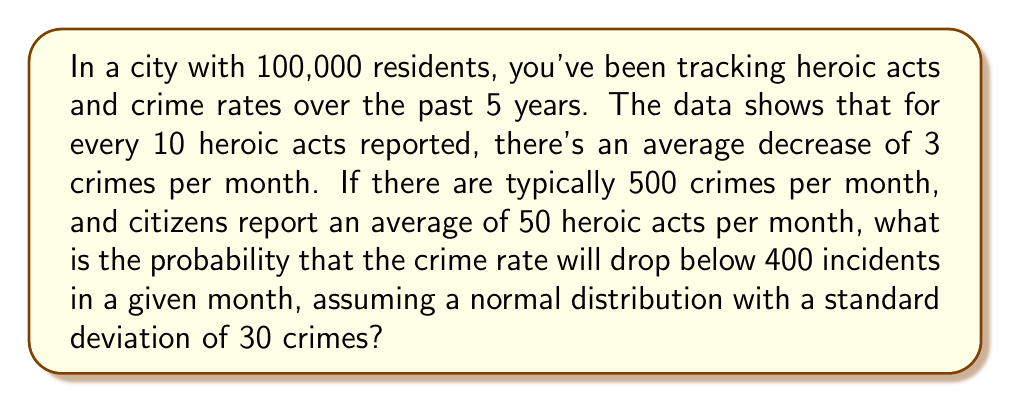Give your solution to this math problem. Let's approach this step-by-step:

1) First, calculate the expected reduction in crimes:
   $50 \text{ heroic acts} \times \frac{3 \text{ crimes reduced}}{10 \text{ heroic acts}} = 15 \text{ crimes reduced}$

2) The new expected number of crimes:
   $500 - 15 = 485 \text{ crimes}$

3) We want to find the probability of having fewer than 400 crimes. We can use the z-score formula:
   $z = \frac{x - \mu}{\sigma}$

   Where:
   $x = 400$ (our target)
   $\mu = 485$ (our new mean)
   $\sigma = 30$ (given standard deviation)

4) Plugging in the values:
   $z = \frac{400 - 485}{30} = -2.83$

5) This z-score represents the number of standard deviations below the mean.

6) Using a standard normal distribution table or calculator, we can find the probability of a z-score being less than or equal to -2.83.

7) This probability is approximately 0.0023 or 0.23%
Answer: 0.23% 